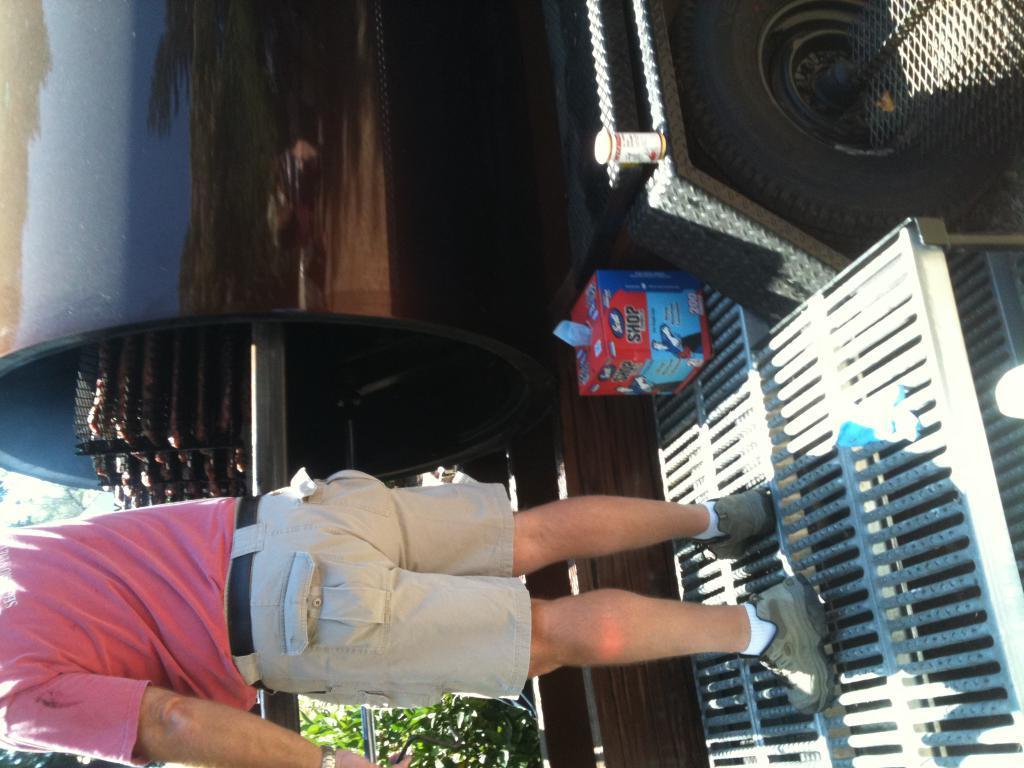Please provide a concise description of this image. In this image I can see a person is standing on a metal rod. In the background I can see a vehicle, fence, some objects and plants. This image is taken may be during a sunny day. 